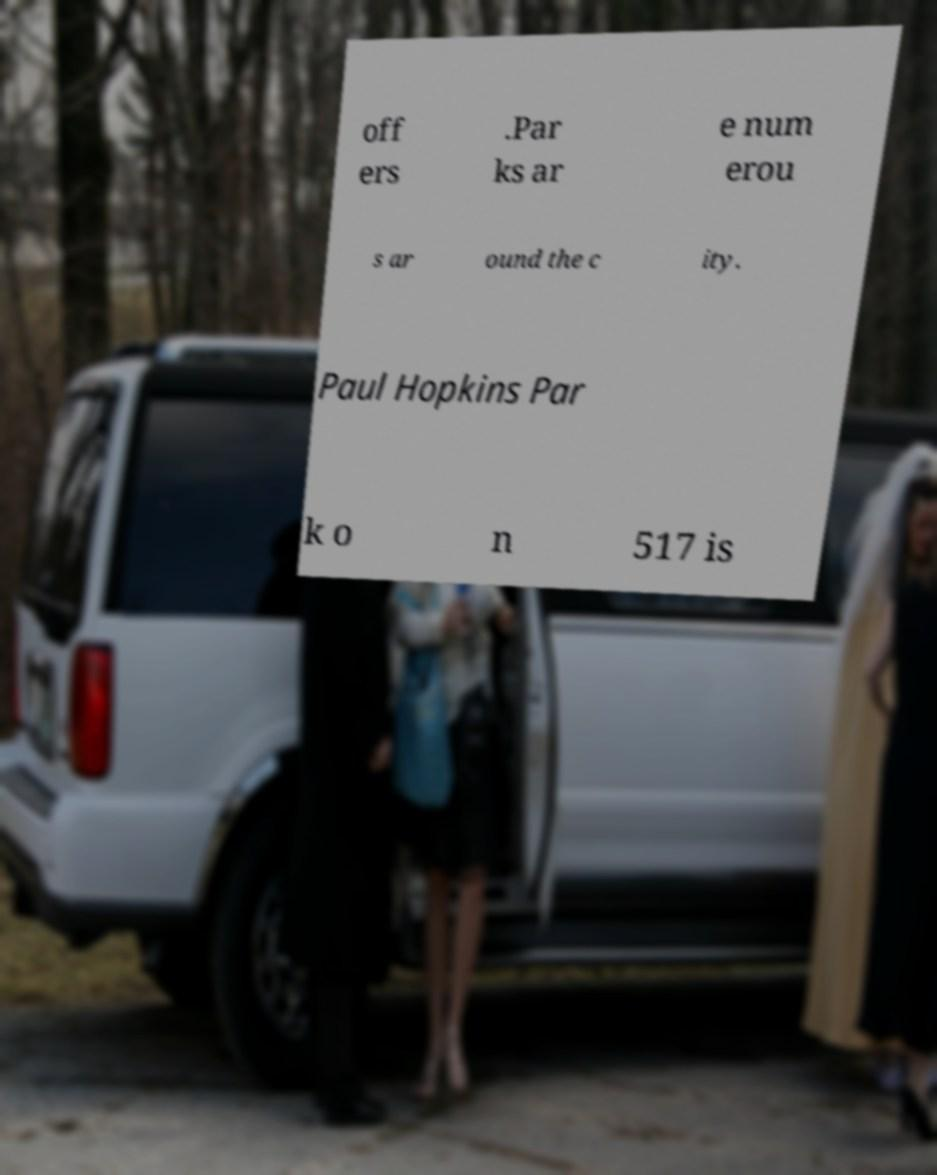There's text embedded in this image that I need extracted. Can you transcribe it verbatim? off ers .Par ks ar e num erou s ar ound the c ity. Paul Hopkins Par k o n 517 is 